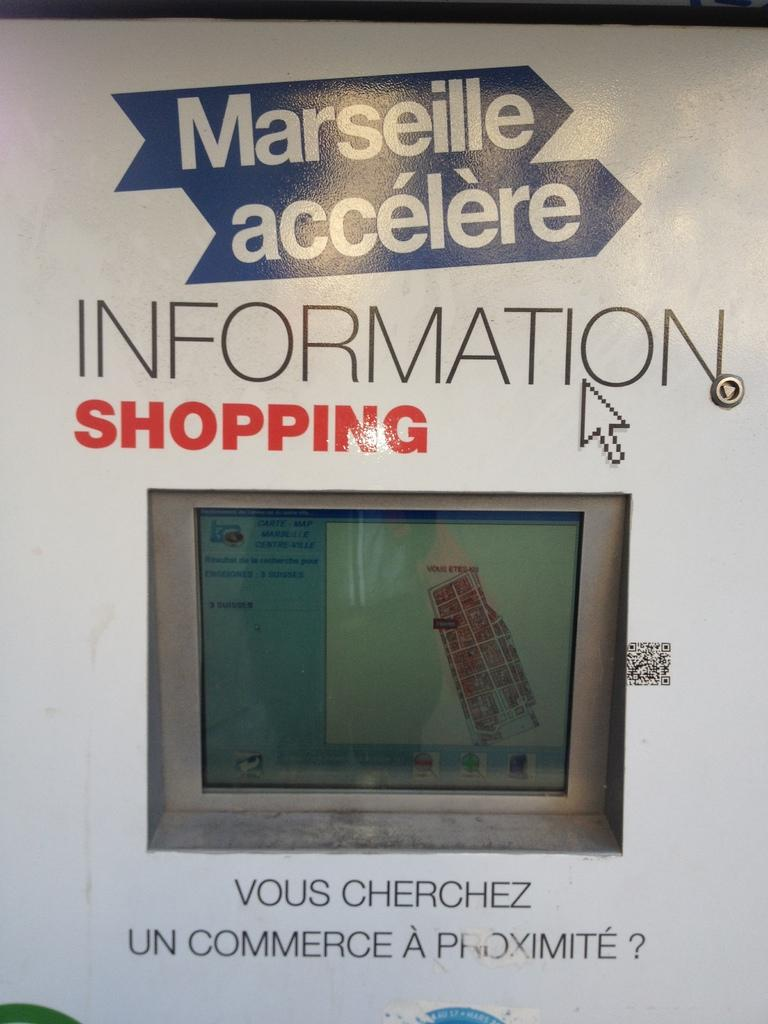<image>
Create a compact narrative representing the image presented. An ad for a TV says Marseille accelere. 